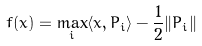<formula> <loc_0><loc_0><loc_500><loc_500>f ( x ) = \max _ { i } \langle x , P _ { i } \rangle - \frac { 1 } { 2 } \| P _ { i } \|</formula> 